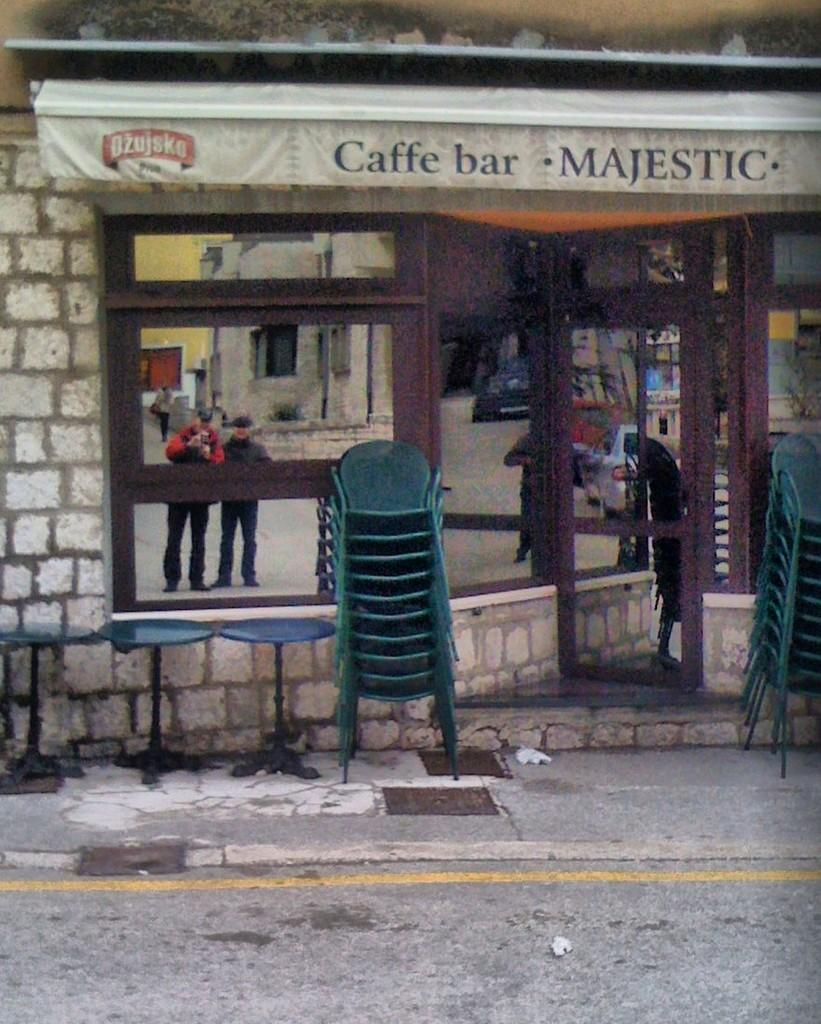What type of furniture is present in the image? There are chairs in the image. What can be seen in the mirror in the image? The mirror in the image shows a reflection of persons. What is the background of the image made up of? There is a wall in the image. What type of kite is being used for treatment in the image? There is no kite present in the image, and no treatment is being performed. What type of discussion is taking place in the image? There is no discussion taking place in the image; it only shows chairs, a mirror, and a wall. 